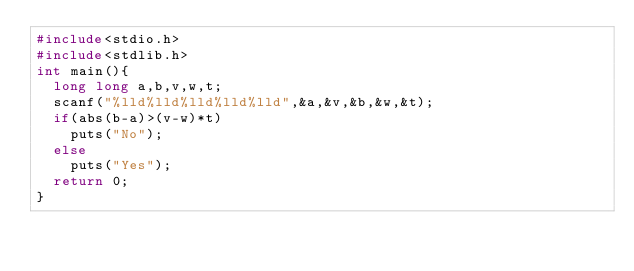Convert code to text. <code><loc_0><loc_0><loc_500><loc_500><_C_>#include<stdio.h>
#include<stdlib.h>
int main(){
  long long a,b,v,w,t;
  scanf("%lld%lld%lld%lld%lld",&a,&v,&b,&w,&t);
  if(abs(b-a)>(v-w)*t)
    puts("No");
  else
    puts("Yes");
  return 0;
}
</code> 